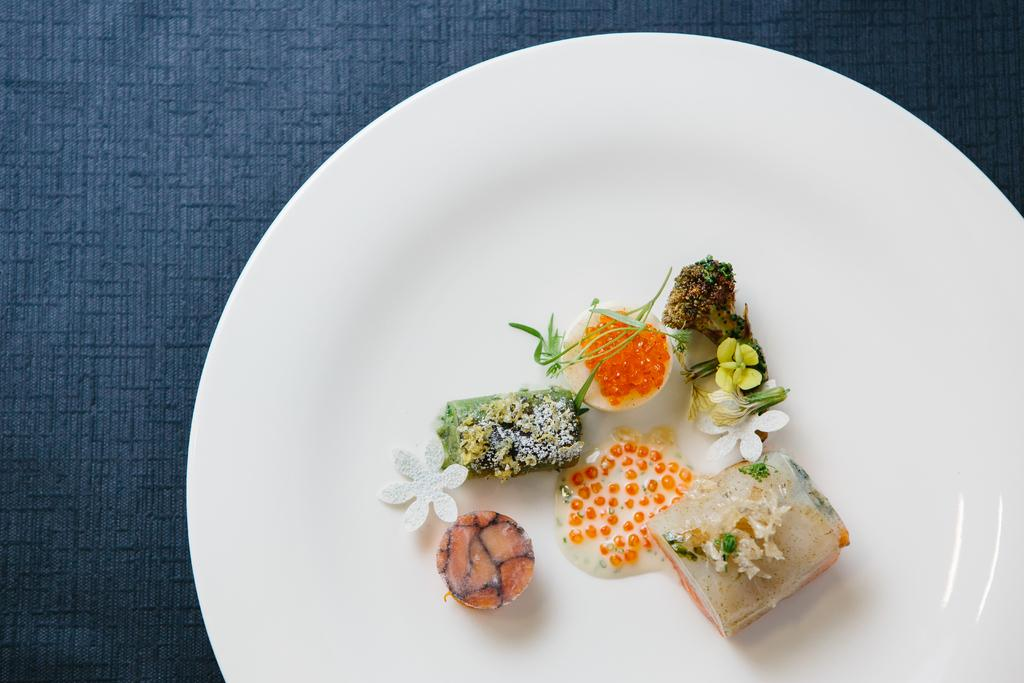What is present on the table in the image? There is food on the table in the image. What color is the table's surface? The table has a blue surface. What type of shirt is being worn by the humor in the image? There is no shirt, humor, or any person or object wearing a shirt in the image. 